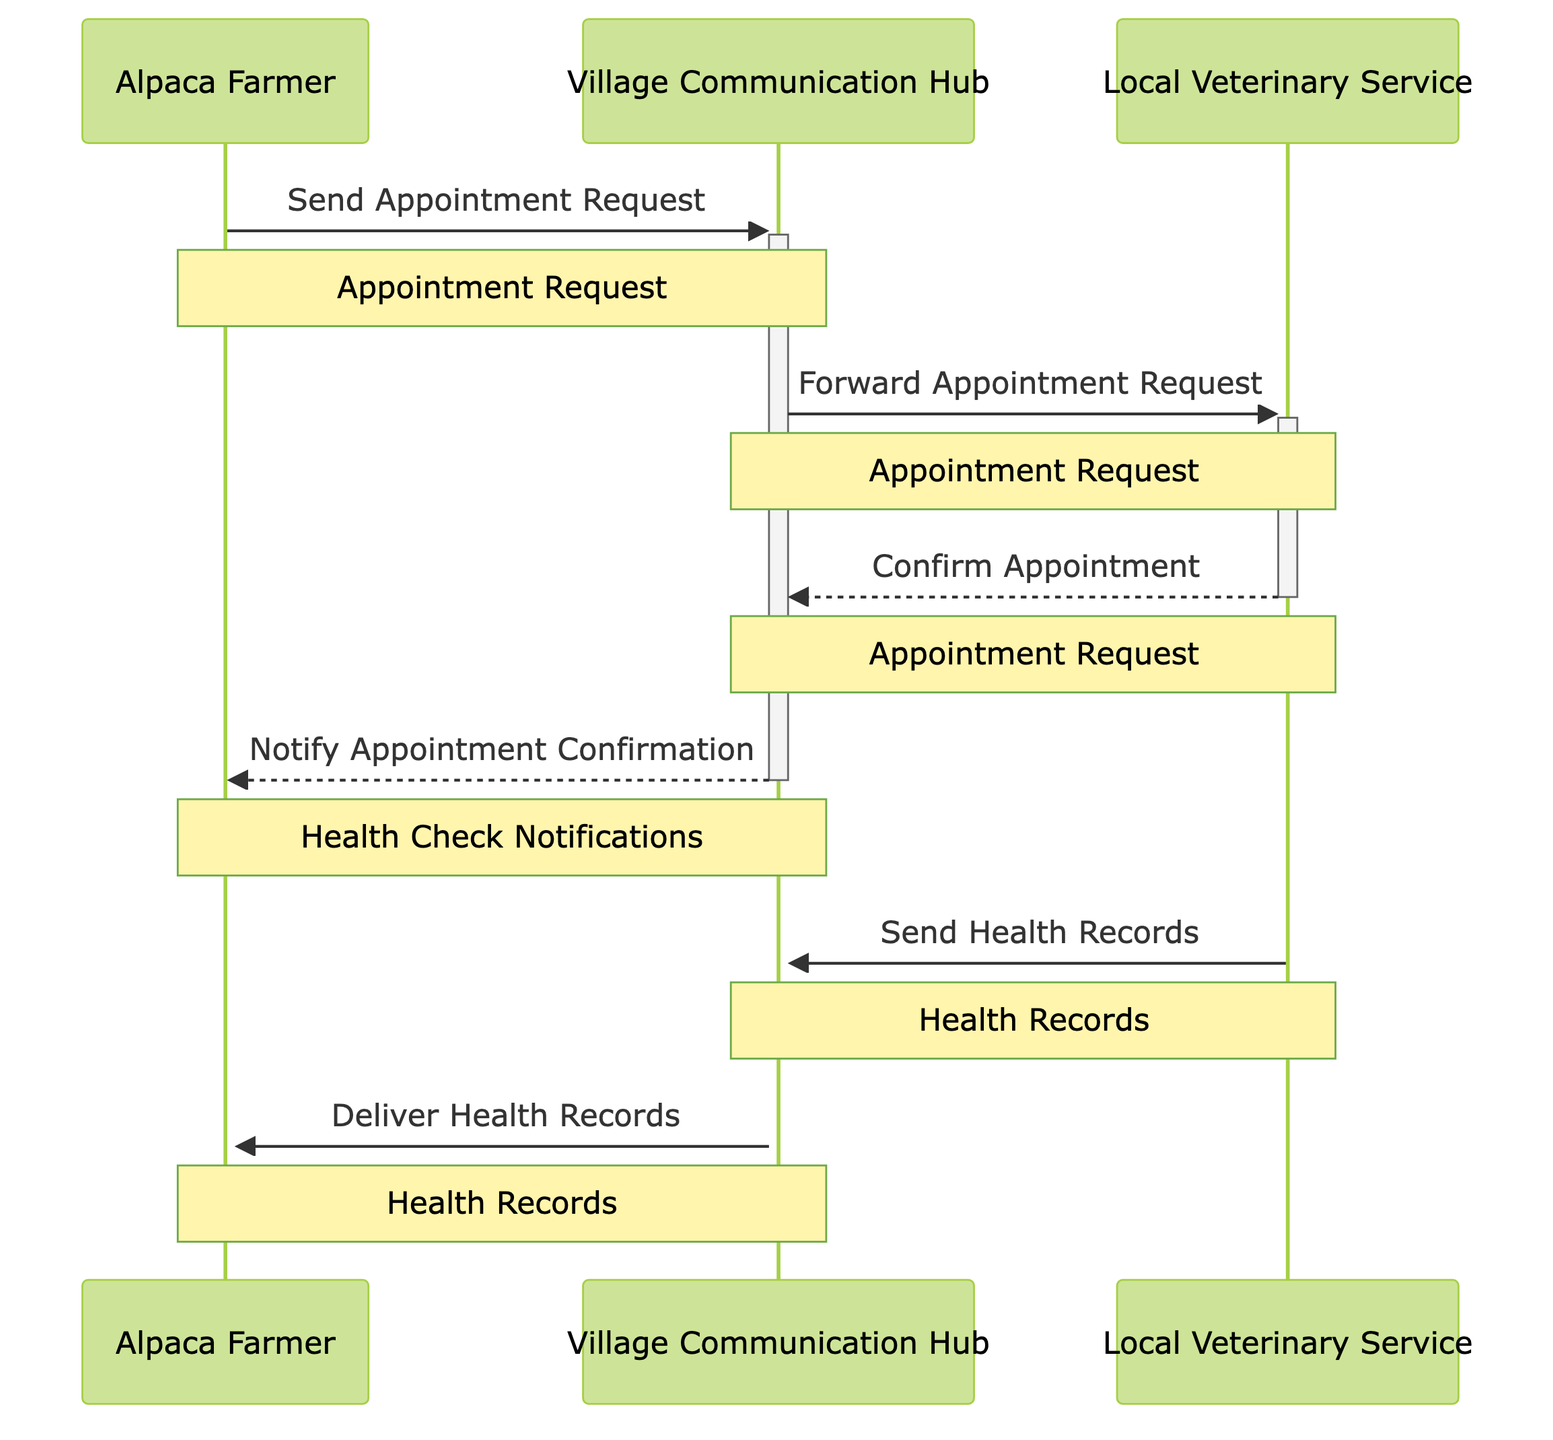What are the three actors in the diagram? The diagram identifies three actors: Alpaca Farmer, Local Veterinary Service, and Village Communication Hub. Each of these roles is distinct and represents a participant in the communication workflow.
Answer: Alpaca Farmer, Local Veterinary Service, Village Communication Hub How many messages are exchanged in total? The diagram details a total of six messages exchanged among the actors. By counting each line that represents a message, we find the total.
Answer: 6 Who does the Alpaca Farmer send the Appointment Request to? The Alpaca Farmer sends the Appointment Request directly to the Village Communication Hub, as indicated by the first message in the sequence.
Answer: Village Communication Hub What type of notification does the Alpaca Farmer receive after the appointment is confirmed? The Alpaca Farmer receives a Health Check Notification after the appointment is confirmed, as denoted in the sequence.
Answer: Health Check Notifications Which object is involved when the Local Veterinary Service confirms the appointment? The object involved during the appointment confirmation from the Local Veterinary Service is the Appointment Request, as shown in the sequence arrows.
Answer: Appointment Request Describe the flow of Health Records from the Local Veterinary Service to the Alpaca Farmer. The Health Records are sent from the Local Veterinary Service to the Village Communication Hub first, and then the Village Communication Hub delivers these records to the Alpaca Farmer. This flow demonstrates two steps: sending and delivering.
Answer: Village Communication Hub What is the second message sent in the workflow? The second message in the sequence is "Forward Appointment Request," which is sent from the Village Communication Hub to the Local Veterinary Service. This reflects the communication process in the workflow.
Answer: Forward Appointment Request What does the Village Communication Hub do after receiving the Health Records? After receiving the Health Records from the Local Veterinary Service, the Village Communication Hub delivers them to the Alpaca Farmer, showing its role as an intermediary in the workflow.
Answer: Deliver Health Records 